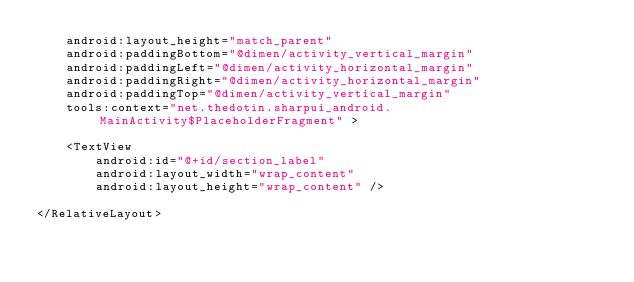Convert code to text. <code><loc_0><loc_0><loc_500><loc_500><_XML_>    android:layout_height="match_parent"
    android:paddingBottom="@dimen/activity_vertical_margin"
    android:paddingLeft="@dimen/activity_horizontal_margin"
    android:paddingRight="@dimen/activity_horizontal_margin"
    android:paddingTop="@dimen/activity_vertical_margin"
    tools:context="net.thedotin.sharpui_android.MainActivity$PlaceholderFragment" >

    <TextView
        android:id="@+id/section_label"
        android:layout_width="wrap_content"
        android:layout_height="wrap_content" />

</RelativeLayout>
</code> 